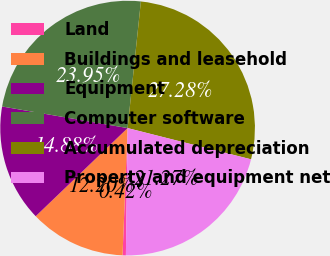Convert chart. <chart><loc_0><loc_0><loc_500><loc_500><pie_chart><fcel>Land<fcel>Buildings and leasehold<fcel>Equipment<fcel>Computer software<fcel>Accumulated depreciation<fcel>Property and equipment net<nl><fcel>0.42%<fcel>12.2%<fcel>14.88%<fcel>23.95%<fcel>27.28%<fcel>21.27%<nl></chart> 